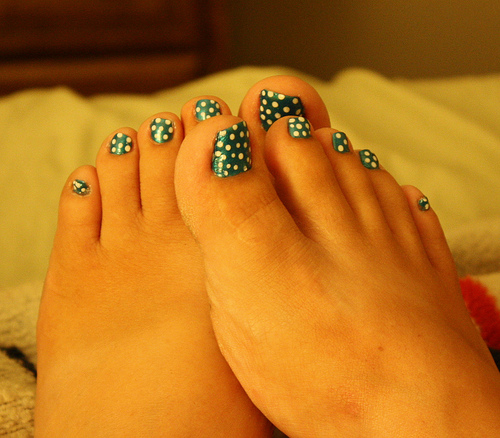<image>
Can you confirm if the nail polish is on the toe? Yes. Looking at the image, I can see the nail polish is positioned on top of the toe, with the toe providing support. 